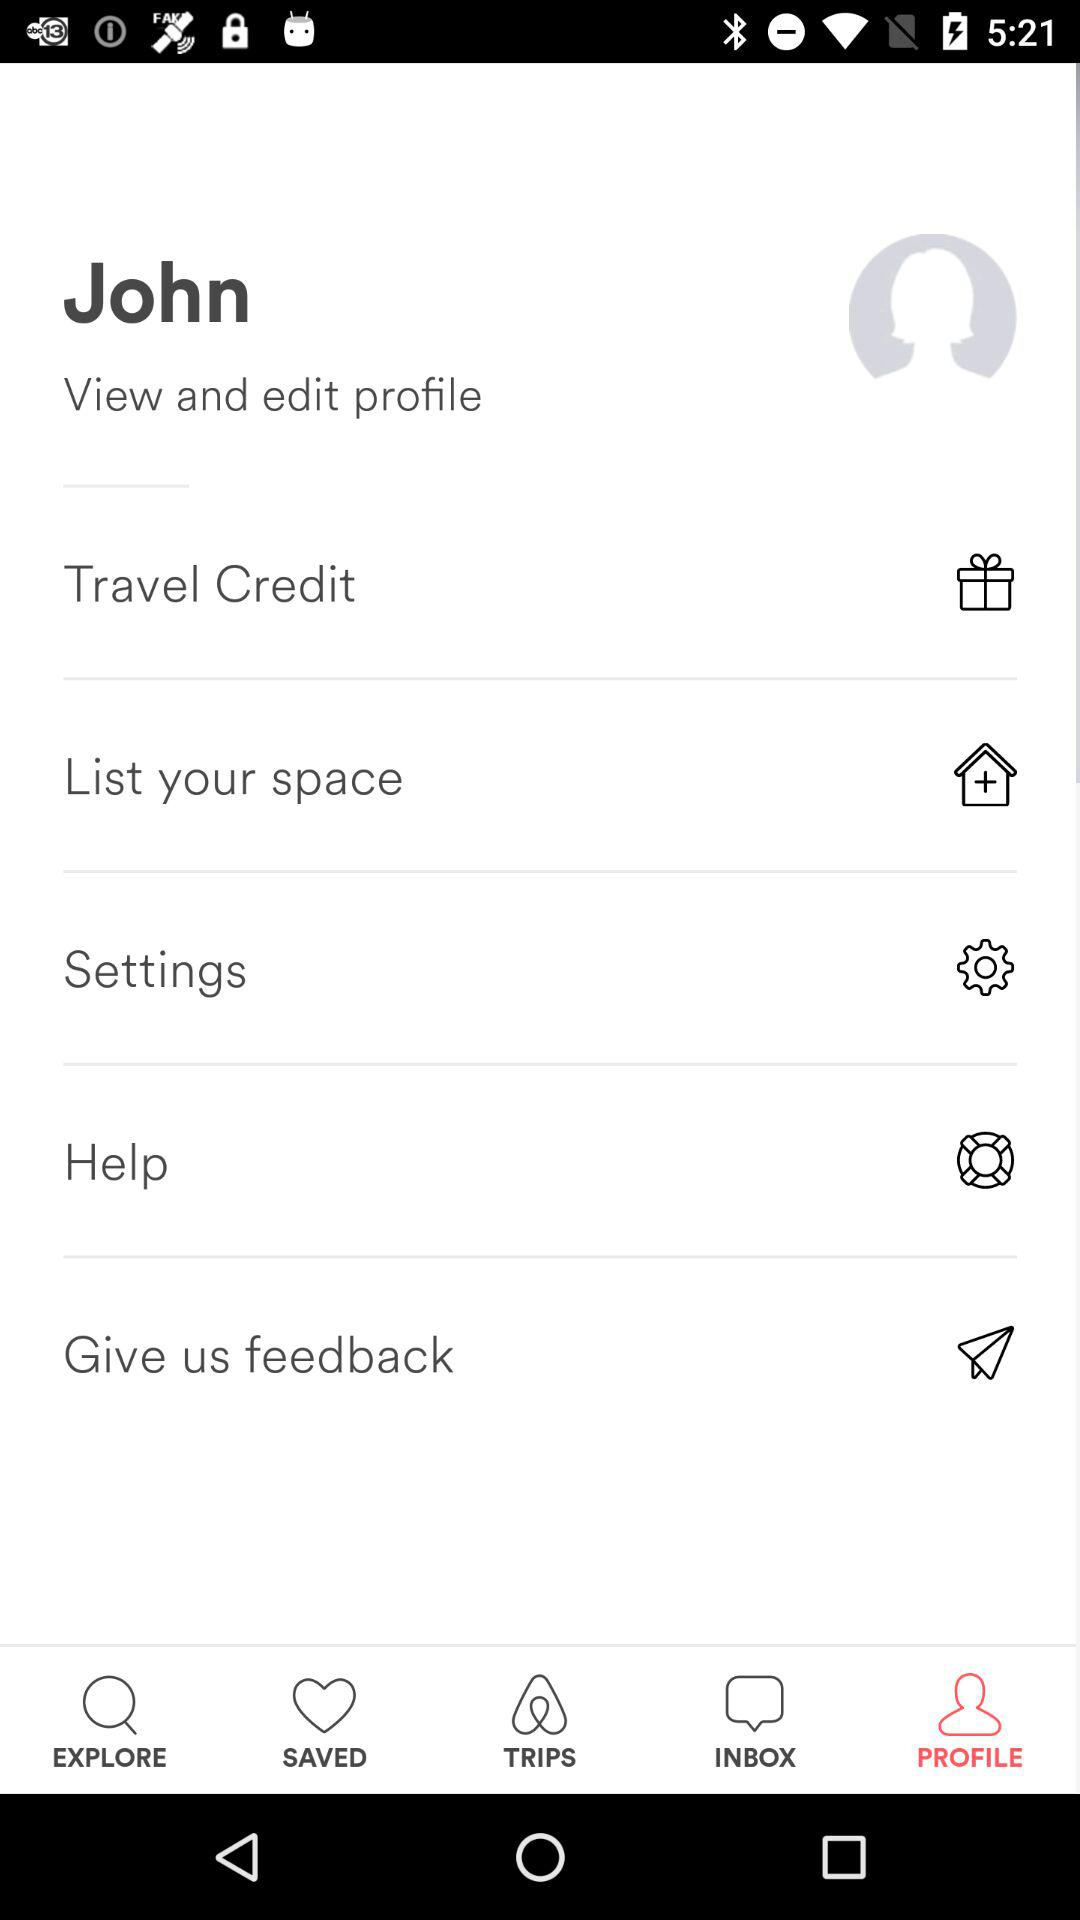What is the name? The name is John. 